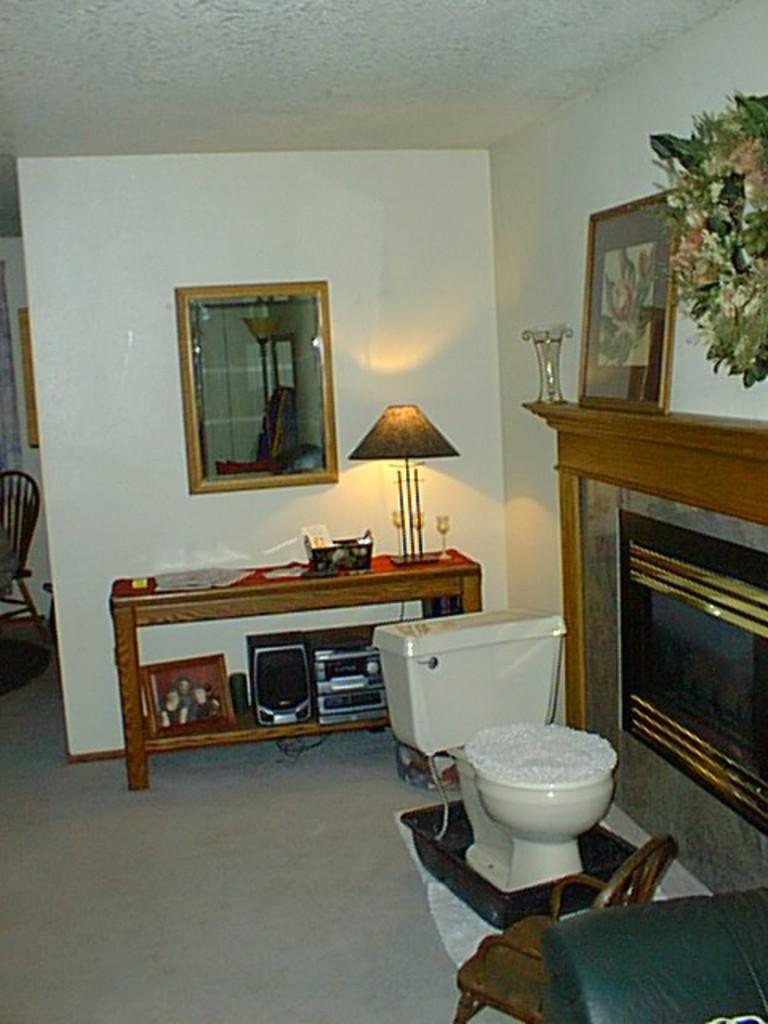In one or two sentences, can you explain what this image depicts? In this image i can see i can see a chair , a toilet on a tub and at the right side there is a flower vase,a frame on a wooden shelf,at the back ground there is a lamp,a papers,and a deck on a table,there is a mirror attached to a wall. 